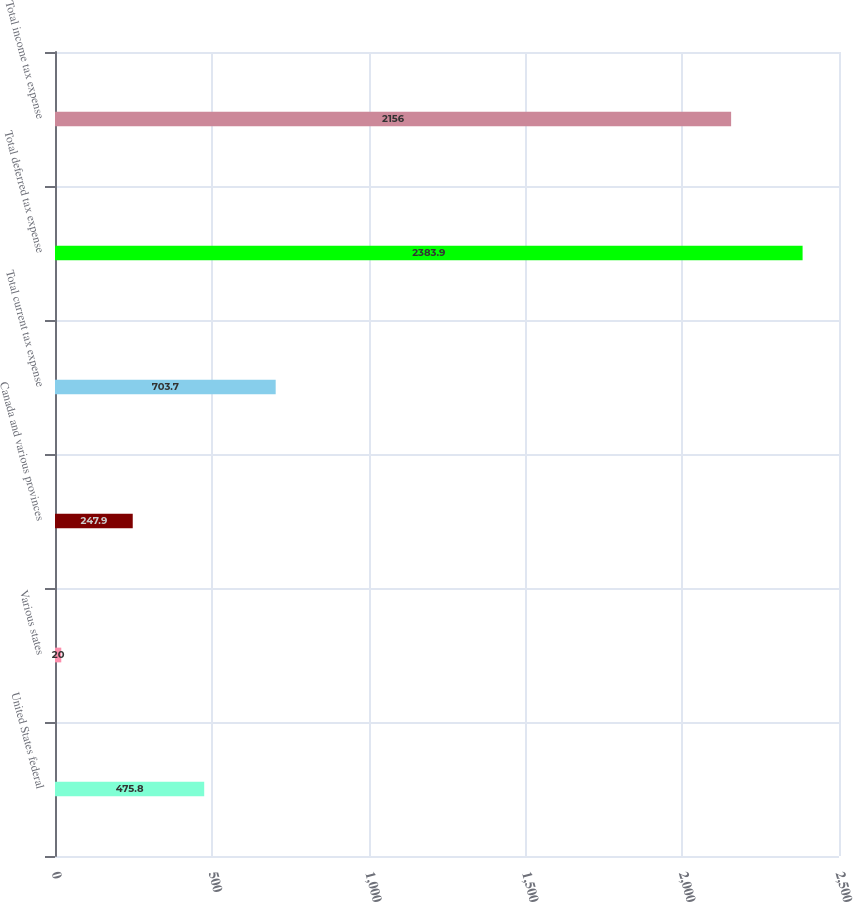Convert chart. <chart><loc_0><loc_0><loc_500><loc_500><bar_chart><fcel>United States federal<fcel>Various states<fcel>Canada and various provinces<fcel>Total current tax expense<fcel>Total deferred tax expense<fcel>Total income tax expense<nl><fcel>475.8<fcel>20<fcel>247.9<fcel>703.7<fcel>2383.9<fcel>2156<nl></chart> 